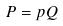<formula> <loc_0><loc_0><loc_500><loc_500>P = p Q</formula> 